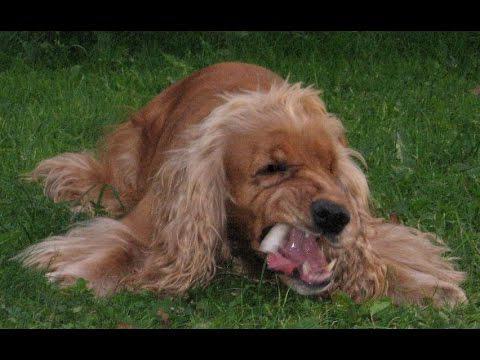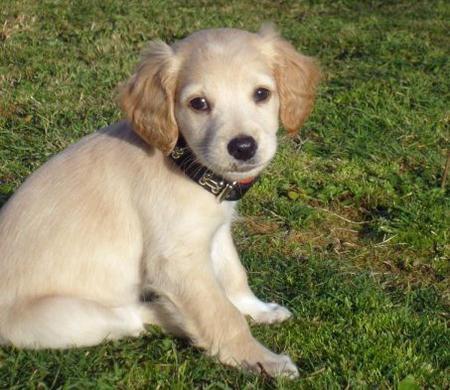The first image is the image on the left, the second image is the image on the right. Examine the images to the left and right. Is the description "One image shows a golden-colored cocker spaniel standing on the grass, body turned to the left." accurate? Answer yes or no. No. The first image is the image on the left, the second image is the image on the right. For the images displayed, is the sentence "One dog is sitting down while the other dog is standing on all fours" factually correct? Answer yes or no. No. 